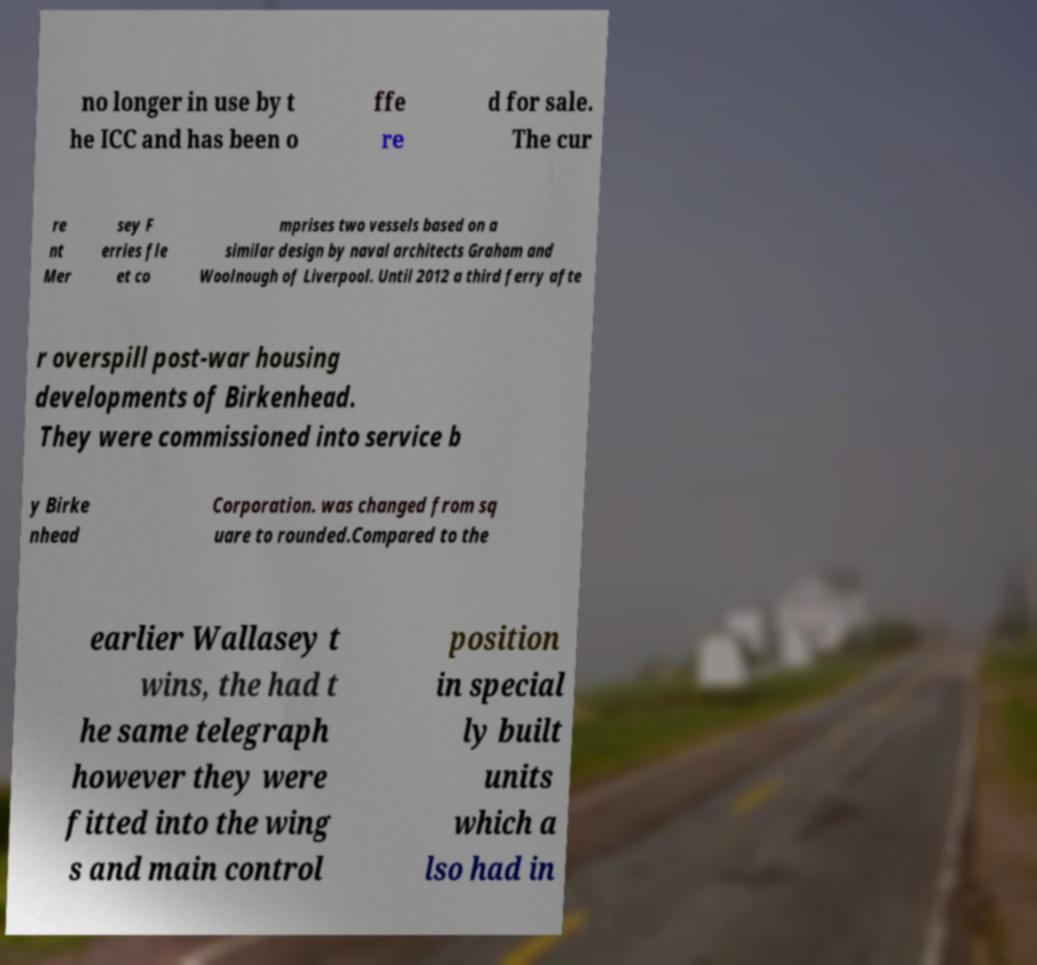Please read and relay the text visible in this image. What does it say? no longer in use by t he ICC and has been o ffe re d for sale. The cur re nt Mer sey F erries fle et co mprises two vessels based on a similar design by naval architects Graham and Woolnough of Liverpool. Until 2012 a third ferry afte r overspill post-war housing developments of Birkenhead. They were commissioned into service b y Birke nhead Corporation. was changed from sq uare to rounded.Compared to the earlier Wallasey t wins, the had t he same telegraph however they were fitted into the wing s and main control position in special ly built units which a lso had in 